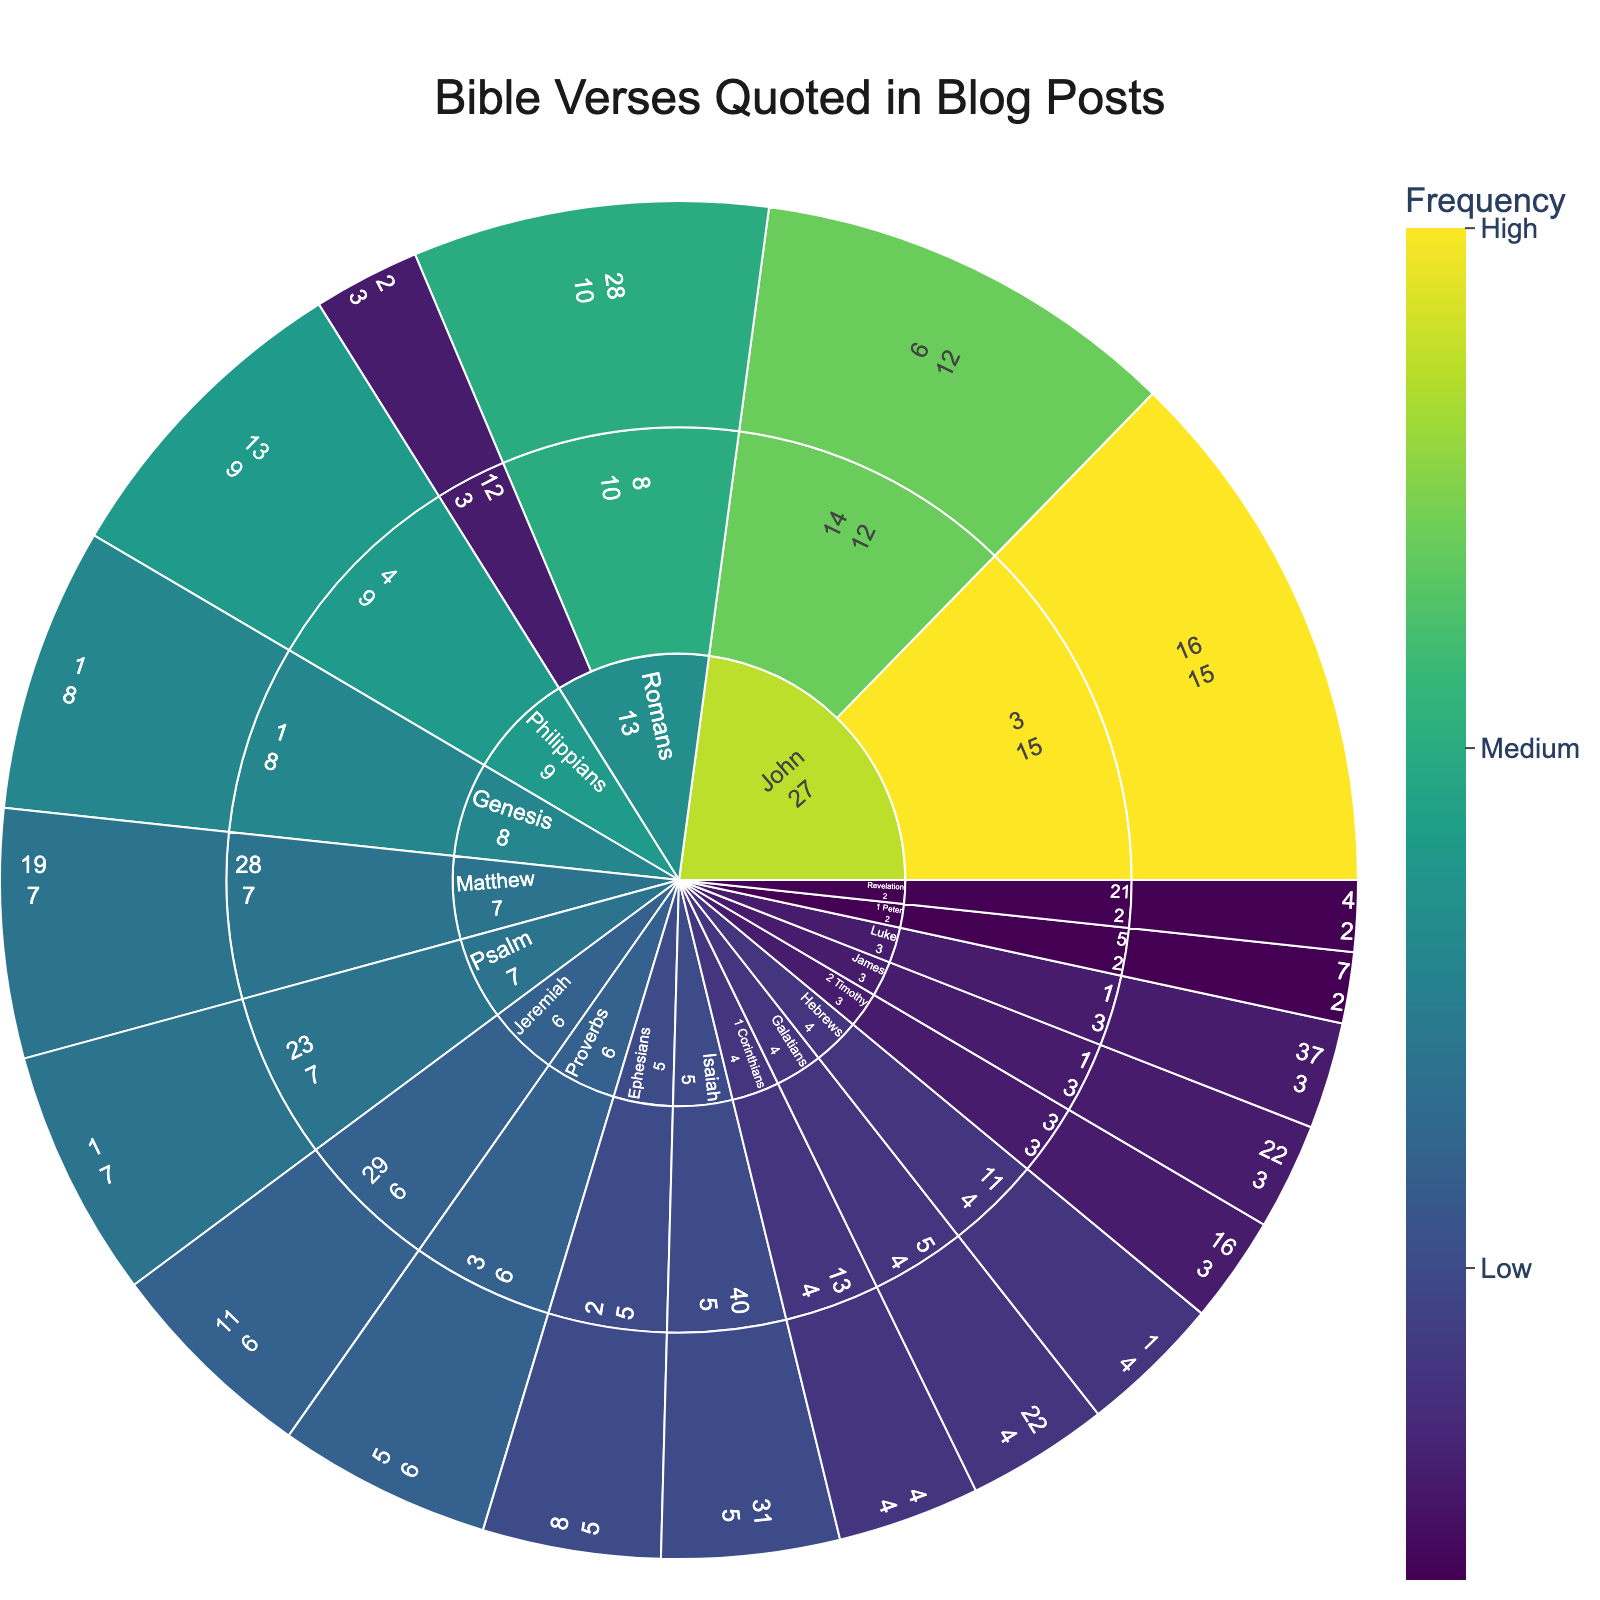What book has the highest count of quoted verses? By looking at the outermost layer of the sunburst plot, we identify the segment with the highest value. The book John appears to have the highest total count.
Answer: John Which chapter in the book of John is quoted more frequently? Within the John segment, we compare the counts for chapters 3 and 14. Chapter 3 has a count of 15, while chapter 14 has a count of 12.
Answer: Chapter 3 How many verses are quoted from the book of Romans? The plot shows verses from Romans chapters 8 and 12. The counts are 10 for verse 28 in chapter 8, and 3 for verse 2 in chapter 12. Adding these gives 10 + 3.
Answer: 13 Which verse in Psalm is the most frequently quoted? The sunburst plot shows a single verse from Psalm, chapter 23 verse 1, with a count of 7.
Answer: Psalm 23:1 Which book from the New Testament has the least quoted verses? By comparing the segment sizes of New Testament books like 1 Peter and Revelation, both have a count of 2. Therefore, both have the least quoted verses.
Answer: 1 Peter, Revelation What is the combined total of verses quoted from John and Romans? From John, we have 15 (John 3:16) plus 12 (John 14:6), totaling 27. From Romans, we have 10 (Romans 8:28) plus 3 (Romans 12:2), totaling 13. Adding these gives 27 + 13.
Answer: 40 Which verse from the Old Testament is the most frequently quoted? The plot shows verses like Genesis 1:1 (8 counts), Psalm 23:1 (7 counts), and Jeremiah 29:11 (6 counts). Genesis 1:1 has the highest count.
Answer: Genesis 1:1 How many books have at least one quoted verse? By counting the unique book segments in the sunburst plot, we find there are verses from 18 different books.
Answer: 18 Which chapter features more quoted verses: Ephesians 2 or Isaiah 40? The plot shows Ephesians 2 has verse 8 with a count of 5, whereas Isaiah 40 has verse 31 with a count of 5. Both chapters have the same count.
Answer: Equal 